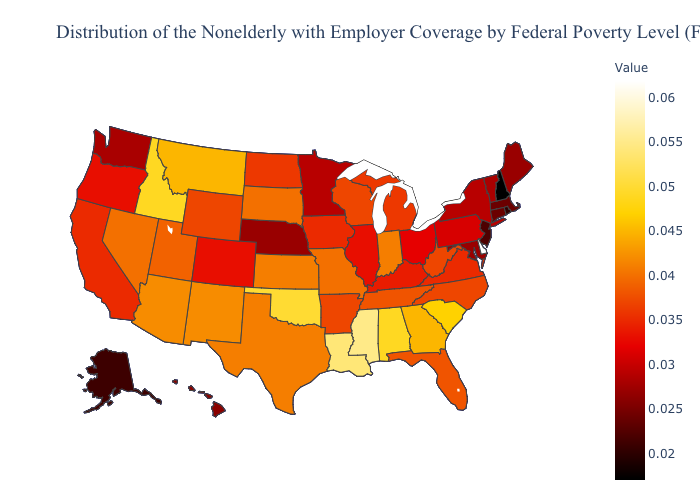Among the states that border Mississippi , which have the highest value?
Keep it brief. Louisiana. Does Colorado have the highest value in the USA?
Short answer required. No. Which states have the lowest value in the USA?
Be succinct. New Hampshire. Among the states that border Mississippi , which have the lowest value?
Quick response, please. Arkansas. Which states have the lowest value in the USA?
Quick response, please. New Hampshire. 